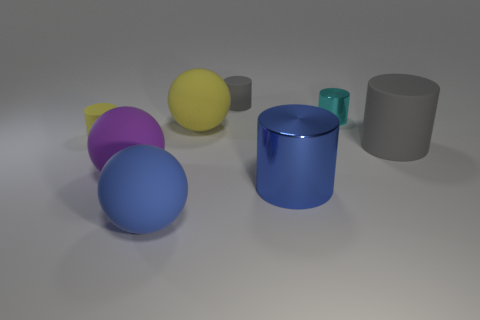There is a object that is the same color as the large metal cylinder; what size is it?
Your answer should be very brief. Large. What material is the yellow thing in front of the yellow sphere?
Give a very brief answer. Rubber. Are there fewer small purple objects than small matte cylinders?
Give a very brief answer. Yes. There is a big purple object; does it have the same shape as the big blue thing right of the small gray rubber object?
Your answer should be compact. No. There is a rubber object that is both right of the purple sphere and in front of the big matte cylinder; what is its shape?
Give a very brief answer. Sphere. Are there an equal number of purple rubber objects in front of the blue cylinder and cyan cylinders that are to the left of the small yellow matte thing?
Keep it short and to the point. Yes. Does the tiny thing that is in front of the yellow sphere have the same shape as the purple matte thing?
Keep it short and to the point. No. What number of blue objects are either small metallic things or big metallic cylinders?
Keep it short and to the point. 1. There is a big purple thing that is the same shape as the big yellow matte thing; what is it made of?
Offer a terse response. Rubber. There is a tiny thing that is behind the tiny metal cylinder; what shape is it?
Provide a succinct answer. Cylinder. 